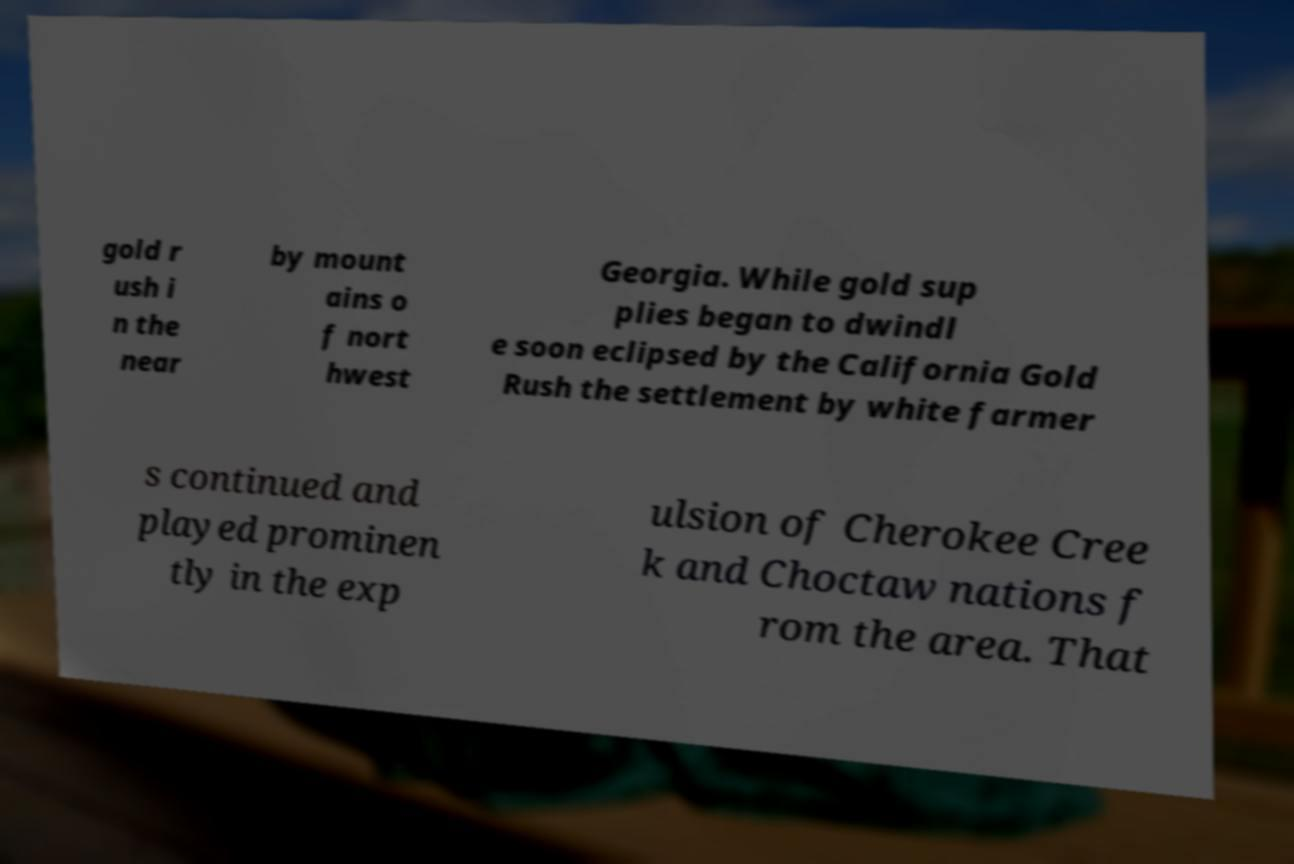Could you assist in decoding the text presented in this image and type it out clearly? gold r ush i n the near by mount ains o f nort hwest Georgia. While gold sup plies began to dwindl e soon eclipsed by the California Gold Rush the settlement by white farmer s continued and played prominen tly in the exp ulsion of Cherokee Cree k and Choctaw nations f rom the area. That 